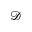Convert formula to latex. <formula><loc_0><loc_0><loc_500><loc_500>\mathcal { D }</formula> 